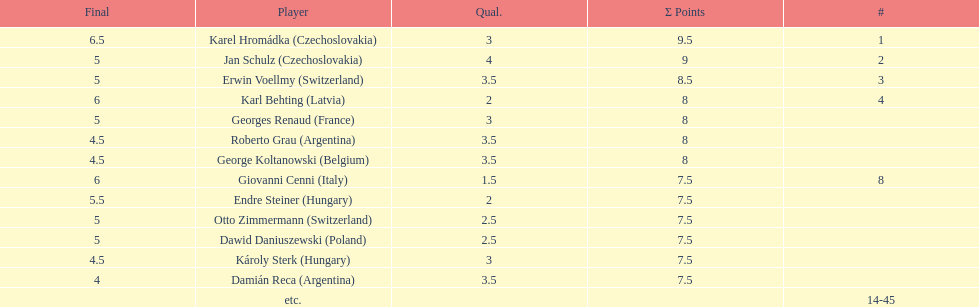How many players had a 8 points? 4. 